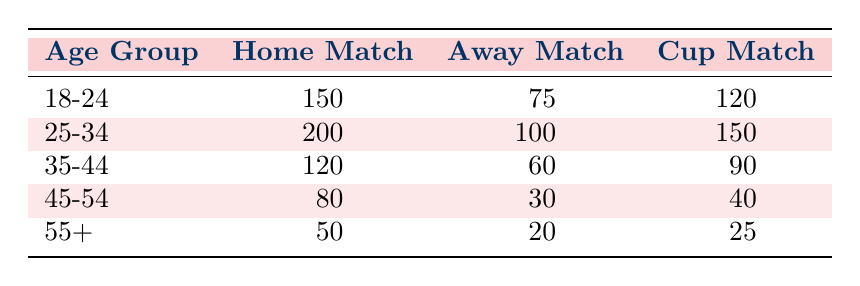What is the attendance for the Home Match among the 25-34 age group? The table states that the attendance for the Home Match in the 25-34 age group is listed directly in the second row under the "Home Match" column, which shows a value of 200.
Answer: 200 How many fans attended Away Matches in the 35-44 age group? The table indicates the attendance for the Away Match specifically for the 35-44 age group in the third row, showing that 60 fans attended.
Answer: 60 What is the total attendance for Cup Matches across all age groups? To find the total attendance for Cup Matches, we sum the attendance values for that category: 120 + 150 + 90 + 40 + 25 = 425.
Answer: 425 Are there more fans in the 18-24 age group for Home Matches than for Away Matches? The attendance for Home Matches in the 18-24 age group is 150, while for Away Matches it is 75. Since 150 is greater than 75, the answer is yes.
Answer: Yes What is the average attendance for Home Matches across all age groups? To calculate the average attendance for Home Matches, we add the numbers for all age groups: 150 + 200 + 120 + 80 + 50 = 600. Since there are 5 age groups, we divide by 5, giving 600 / 5 = 120.
Answer: 120 Which age group had the highest attendance for Away Matches? By reviewing the Away Match attendance values, we observe that the 25-34 age group has the highest attendance with 100, which is greater than the other age groups in that category.
Answer: 25-34 How does the attendance of the 55+ age group compare between Home and Cup Matches? For the 55+ age group, the attendance for Home Matches is 50, while for Cup Matches it is 25. Since 50 is greater than 25, the Home Match attendance is higher.
Answer: Higher in Home Matches Is the total attendance for the 45-54 age group at Away Matches less than that of Home Matches? For the 45-54 age group, 30 fans attended Away Matches while 80 attended Home Matches. Since 30 is less than 80, the statement is true.
Answer: Yes What is the difference in attendance between the 25-34 age group for Home Matches and Cup Matches? To find the difference, we take the Home Matches attendance for the 25-34 age group (200) and subtract the Cup Matches attendance (150): 200 - 150 = 50.
Answer: 50 